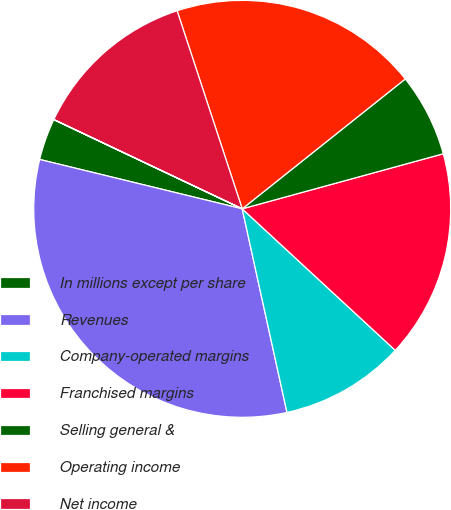<chart> <loc_0><loc_0><loc_500><loc_500><pie_chart><fcel>In millions except per share<fcel>Revenues<fcel>Company-operated margins<fcel>Franchised margins<fcel>Selling general &<fcel>Operating income<fcel>Net income<fcel>Earnings per common<nl><fcel>3.23%<fcel>32.25%<fcel>9.68%<fcel>16.13%<fcel>6.45%<fcel>19.35%<fcel>12.9%<fcel>0.01%<nl></chart> 